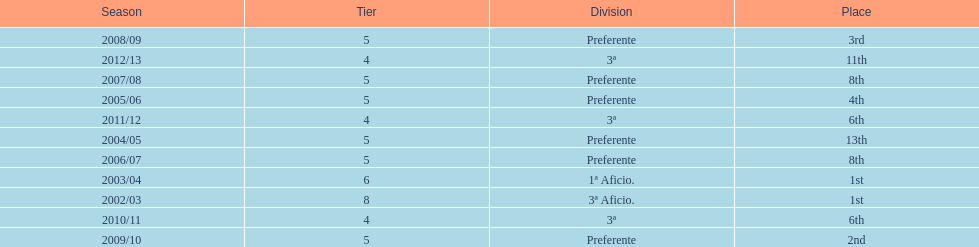Which division placed more than aficio 1a and 3a? Preferente. 